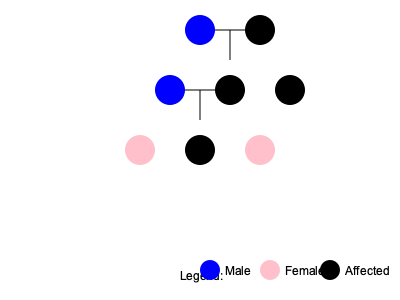Based on the pedigree chart provided, what is the most likely mode of inheritance for this rare condition? To determine the mode of inheritance, we need to analyze the pattern of affected individuals across generations:

1. The condition appears in both males and females, ruling out Y-linked inheritance.

2. The condition does not skip generations, which is typical of dominant traits.

3. We see affected individuals in each generation, which is characteristic of autosomal dominant inheritance.

4. There are instances of affected individuals having an affected parent (e.g., the affected female in generation II has an affected mother).

5. Approximately 50% of the offspring of an affected individual are affected, which is consistent with autosomal dominant inheritance.

6. The condition is passed from both males and females to their children, ruling out X-linked dominant inheritance (which would show no male-to-male transmission).

7. The pattern does not fit autosomal recessive inheritance, which typically shows:
   - Affected individuals often born to unaffected parents
   - The condition may skip generations
   - Both parents must be carriers for the child to be affected

Given these observations, the most likely mode of inheritance for this rare condition is autosomal dominant.
Answer: Autosomal dominant 